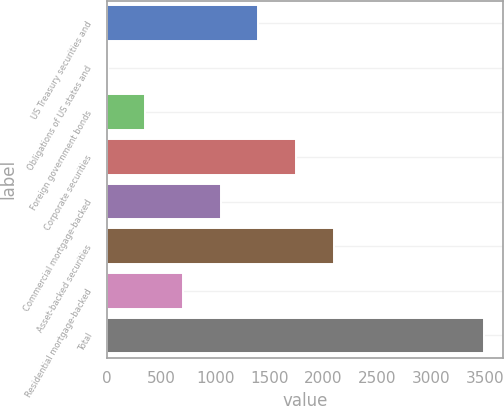<chart> <loc_0><loc_0><loc_500><loc_500><bar_chart><fcel>US Treasury securities and<fcel>Obligations of US states and<fcel>Foreign government bonds<fcel>Corporate securities<fcel>Commercial mortgage-backed<fcel>Asset-backed securities<fcel>Residential mortgage-backed<fcel>Total<nl><fcel>1400<fcel>6<fcel>354.5<fcel>1748.5<fcel>1051.5<fcel>2097<fcel>703<fcel>3491<nl></chart> 